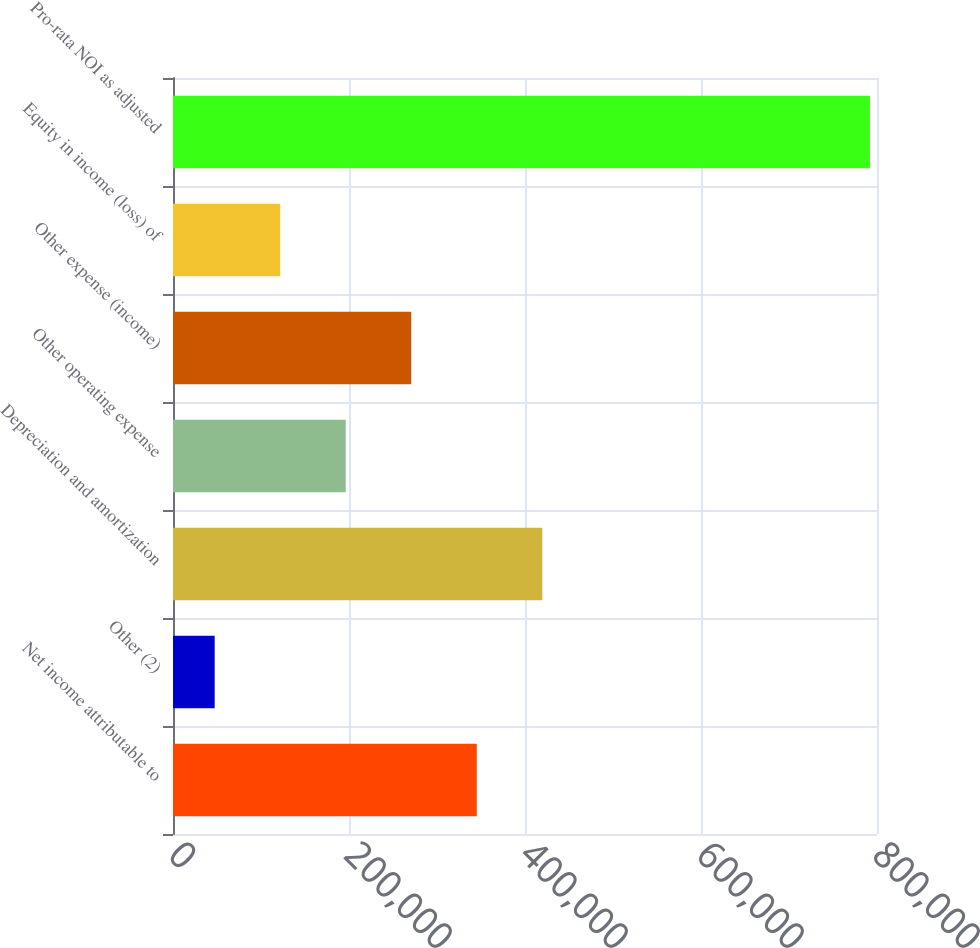<chart> <loc_0><loc_0><loc_500><loc_500><bar_chart><fcel>Net income attributable to<fcel>Other (2)<fcel>Depreciation and amortization<fcel>Other operating expense<fcel>Other expense (income)<fcel>Equity in income (loss) of<fcel>Pro-rata NOI as adjusted<nl><fcel>345207<fcel>47357<fcel>419670<fcel>196282<fcel>270744<fcel>121820<fcel>791982<nl></chart> 